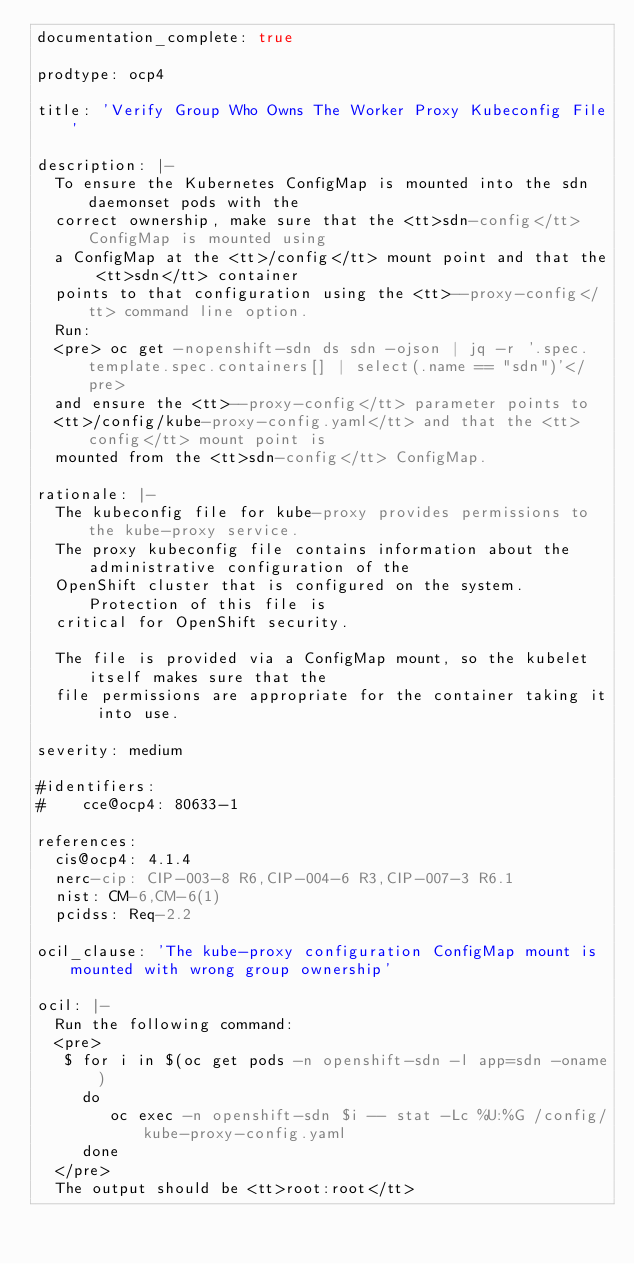Convert code to text. <code><loc_0><loc_0><loc_500><loc_500><_YAML_>documentation_complete: true

prodtype: ocp4

title: 'Verify Group Who Owns The Worker Proxy Kubeconfig File'

description: |-
  To ensure the Kubernetes ConfigMap is mounted into the sdn daemonset pods with the
  correct ownership, make sure that the <tt>sdn-config</tt> ConfigMap is mounted using
  a ConfigMap at the <tt>/config</tt> mount point and that the <tt>sdn</tt> container
  points to that configuration using the <tt>--proxy-config</tt> command line option.
  Run:
  <pre> oc get -nopenshift-sdn ds sdn -ojson | jq -r '.spec.template.spec.containers[] | select(.name == "sdn")'</pre>
  and ensure the <tt>--proxy-config</tt> parameter points to 
  <tt>/config/kube-proxy-config.yaml</tt> and that the <tt>config</tt> mount point is
  mounted from the <tt>sdn-config</tt> ConfigMap.

rationale: |-
  The kubeconfig file for kube-proxy provides permissions to the kube-proxy service.
  The proxy kubeconfig file contains information about the administrative configuration of the
  OpenShift cluster that is configured on the system. Protection of this file is
  critical for OpenShift security.

  The file is provided via a ConfigMap mount, so the kubelet itself makes sure that the
  file permissions are appropriate for the container taking it into use.

severity: medium

#identifiers:
#    cce@ocp4: 80633-1

references:
  cis@ocp4: 4.1.4
  nerc-cip: CIP-003-8 R6,CIP-004-6 R3,CIP-007-3 R6.1
  nist: CM-6,CM-6(1)
  pcidss: Req-2.2

ocil_clause: 'The kube-proxy configuration ConfigMap mount is mounted with wrong group ownership'

ocil: |-
  Run the following command:
  <pre>
   $ for i in $(oc get pods -n openshift-sdn -l app=sdn -oname)
     do
        oc exec -n openshift-sdn $i -- stat -Lc %U:%G /config/kube-proxy-config.yaml
     done
  </pre>
  The output should be <tt>root:root</tt>
</code> 